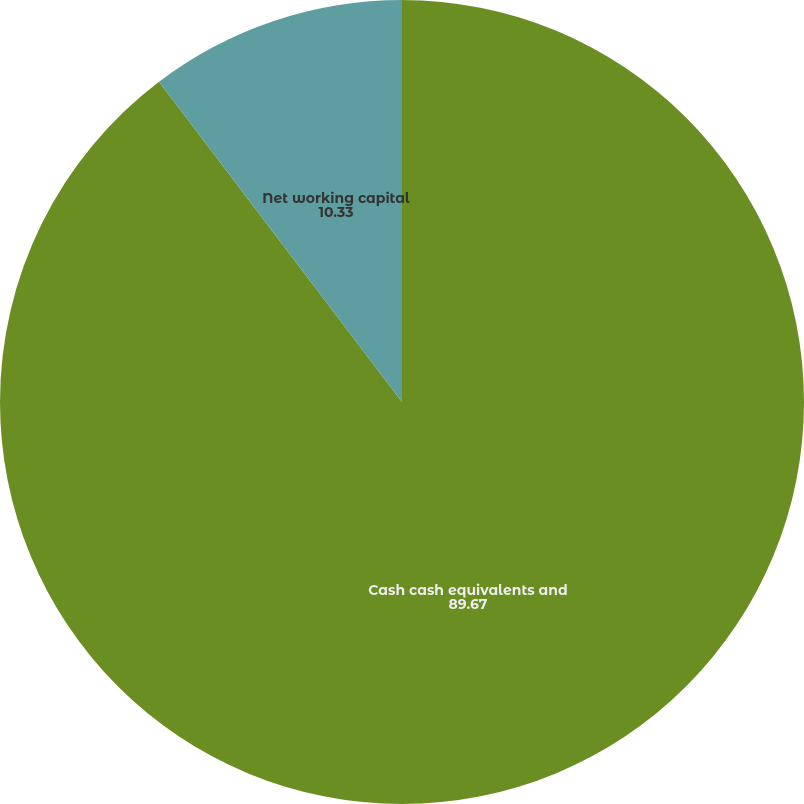Convert chart. <chart><loc_0><loc_0><loc_500><loc_500><pie_chart><fcel>Cash cash equivalents and<fcel>Net working capital<nl><fcel>89.67%<fcel>10.33%<nl></chart> 